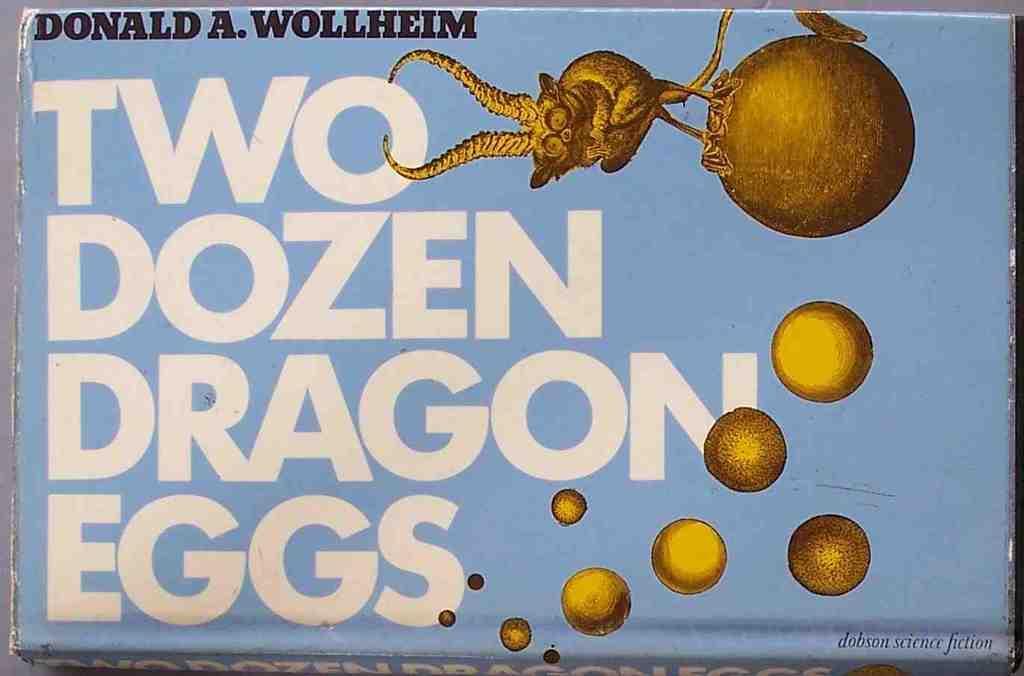Describe this image in one or two sentences. By seeing this image we can say it is a poster on which some text and cartoon figures are there. 